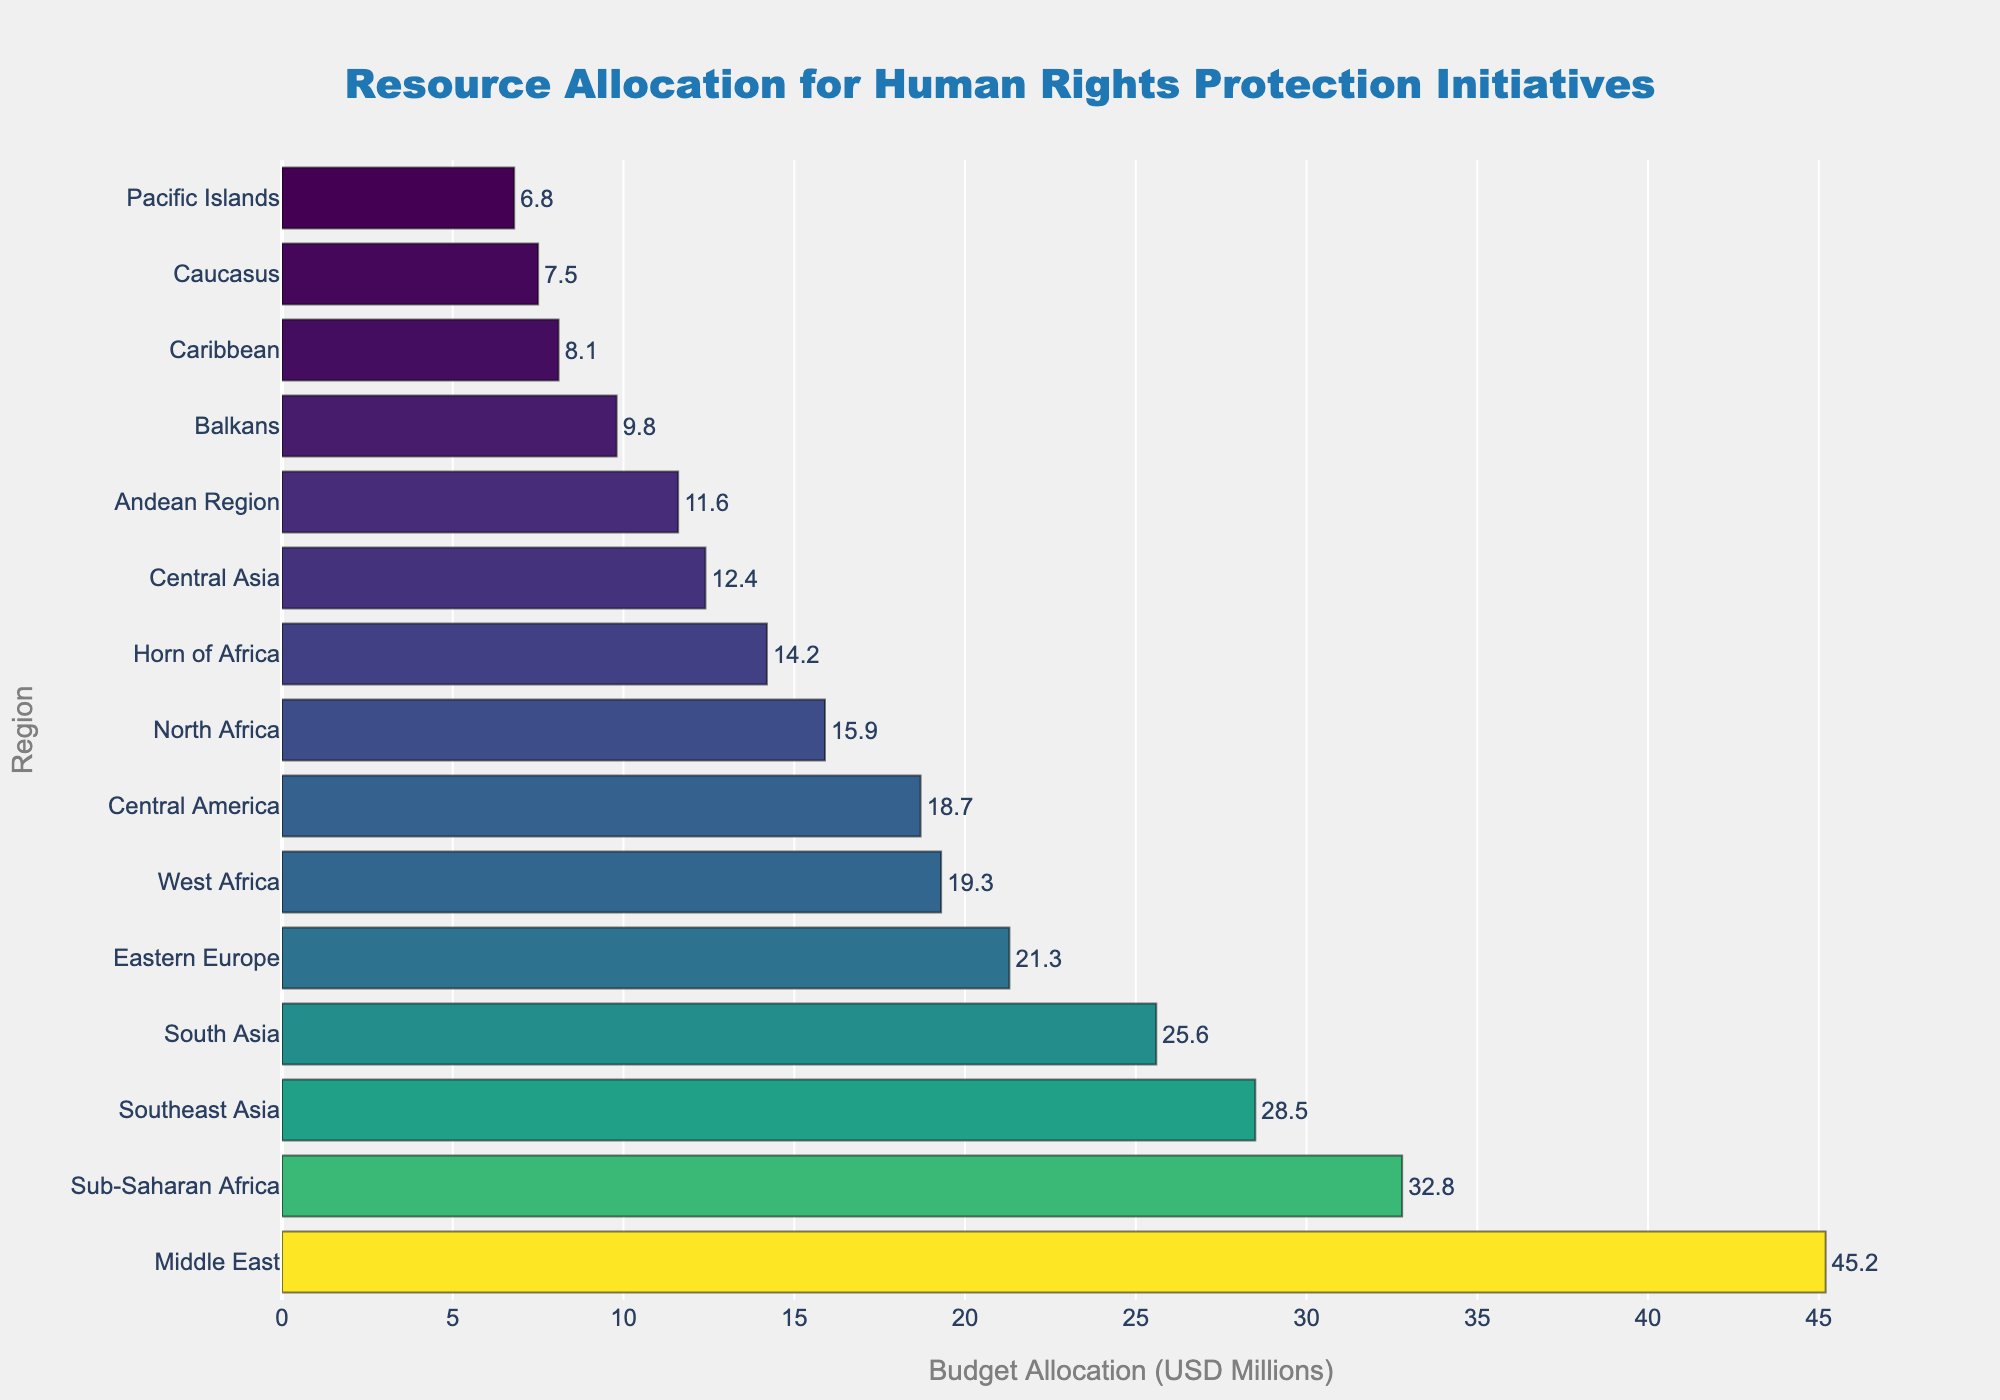Which region has the highest budget allocation? The Middle East has the highest bar, indicating the highest budget allocation.
Answer: Middle East Which region has the lowest budget allocation? The Pacific Islands has the shortest bar, indicating the lowest budget allocation in the chart.
Answer: Pacific Islands How much more budget does the Middle East receive compared to Eastern Europe? The Middle East receives 45.2 million USD, and Eastern Europe receives 21.3 million USD. The difference is 45.2 - 21.3 = 23.9 million USD.
Answer: 23.9 million USD What is the total budget allocated across all regions? Sum the budget allocations for each region: 45.2 + 32.8 + 28.5 + 21.3 + 18.7 + 25.6 + 15.9 + 12.4 + 9.8 + 7.5 + 14.2 + 11.6 + 19.3 + 6.8 + 8.1 = 277.7 million USD.
Answer: 277.7 million USD Which regions have a budget allocation greater than 20 million USD? Regions with bars longer than 20 million USD are: Middle East, Sub-Saharan Africa, Southeast Asia, Eastern Europe, and South Asia.
Answer: Middle East, Sub-Saharan Africa, Southeast Asia, Eastern Europe, South Asia What is the average budget allocation for regions in the figure? Divide the total budget (277.7 million USD) by the number of regions (15): 277.7 / 15 = 18.51 million USD.
Answer: 18.51 million USD How does the budget allocation for South Asia compare to Central America? South Asia's allocation is 25.6 million USD and Central America's allocation is 18.7 million USD. South Asia's allocation is higher.
Answer: South Asia's allocation is higher What is the combined budget allocation for the regions in Central Asia and South Asia? Add the budget allocation for both regions: Central Asia (12.4) and South Asia (25.6): 12.4 + 25.6 = 38 million USD.
Answer: 38 million USD Which region ranks third in terms of budget allocation? The third longest bar corresponds to Southeast Asia, indicating it is the third in budget allocation.
Answer: Southeast Asia How many regions have a budget allocation of less than 10 million USD? Regions with bars shorter than 10 million USD are: Balkans, Caucasus, Andean Region, Pacific Islands, and Caribbean. There are 5 such regions.
Answer: 5 regions 